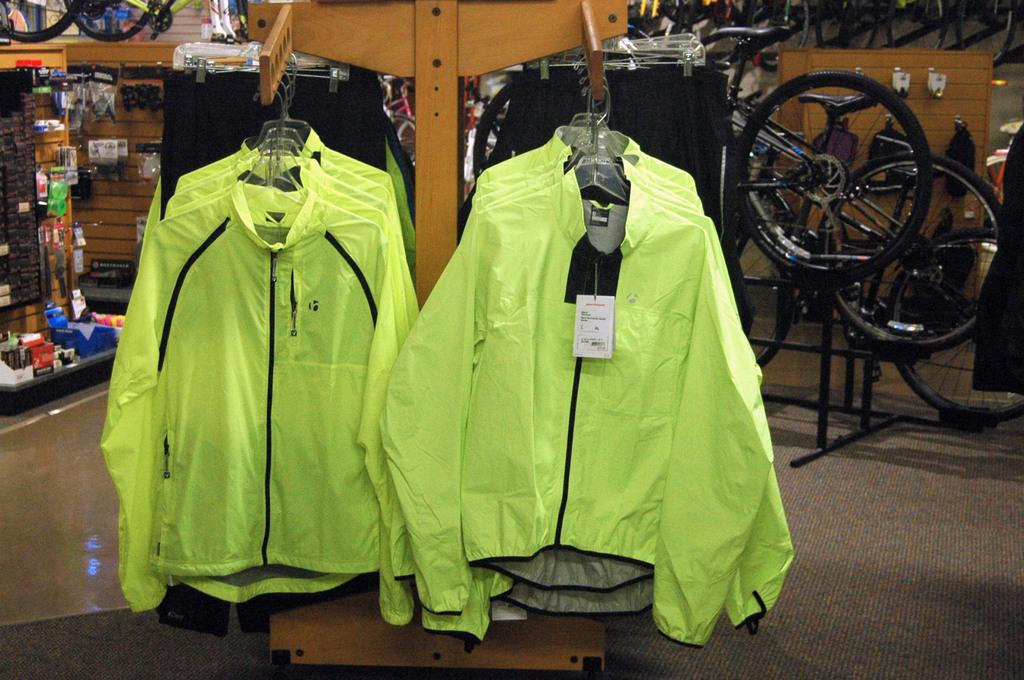What is hanging on the hanger hooks in the image? There are jackets hanged with hanger hooks in the image. What type of transportation can be seen in the image? There are bicycles in the image. Where are the objects located in the image? The objects are on the left side of the image. What surface is visible in the image? The image shows a floor. How many mice are running around on the floor in the image? There are no mice present in the image; it only shows jackets, bicycles, and objects on the left side. What type of town is depicted in the image? There is no town depicted in the image; it only shows jackets, bicycles, and objects on the left side. 